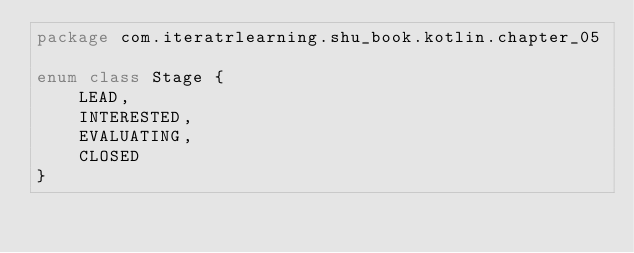Convert code to text. <code><loc_0><loc_0><loc_500><loc_500><_Kotlin_>package com.iteratrlearning.shu_book.kotlin.chapter_05

enum class Stage {
    LEAD,
    INTERESTED,
    EVALUATING,
    CLOSED
}
</code> 